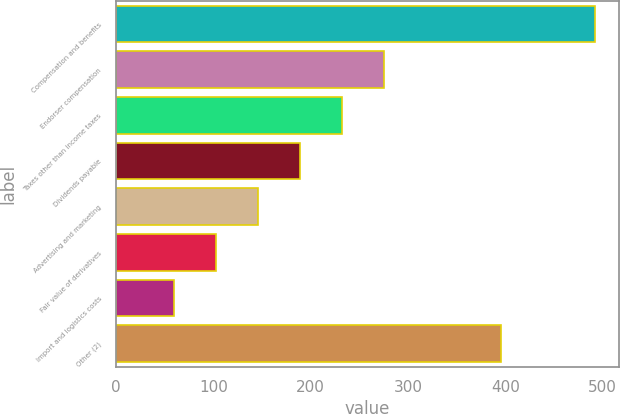Convert chart. <chart><loc_0><loc_0><loc_500><loc_500><bar_chart><fcel>Compensation and benefits<fcel>Endorser compensation<fcel>Taxes other than income taxes<fcel>Dividends payable<fcel>Advertising and marketing<fcel>Fair value of derivatives<fcel>Import and logistics costs<fcel>Other (2)<nl><fcel>491.9<fcel>275.65<fcel>232.4<fcel>189.15<fcel>145.9<fcel>102.65<fcel>59.4<fcel>396.1<nl></chart> 